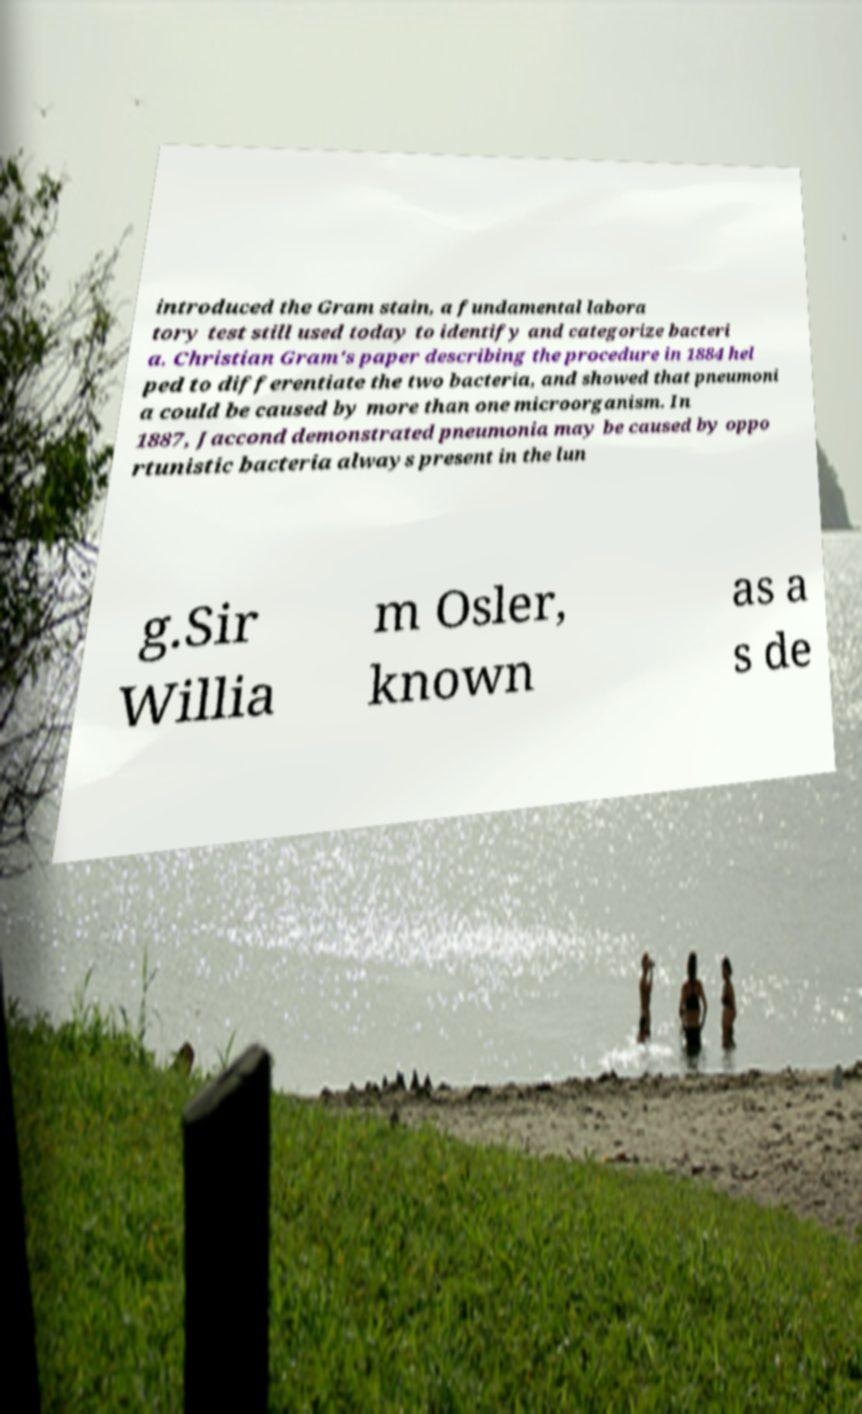Please identify and transcribe the text found in this image. introduced the Gram stain, a fundamental labora tory test still used today to identify and categorize bacteri a. Christian Gram's paper describing the procedure in 1884 hel ped to differentiate the two bacteria, and showed that pneumoni a could be caused by more than one microorganism. In 1887, Jaccond demonstrated pneumonia may be caused by oppo rtunistic bacteria always present in the lun g.Sir Willia m Osler, known as a s de 